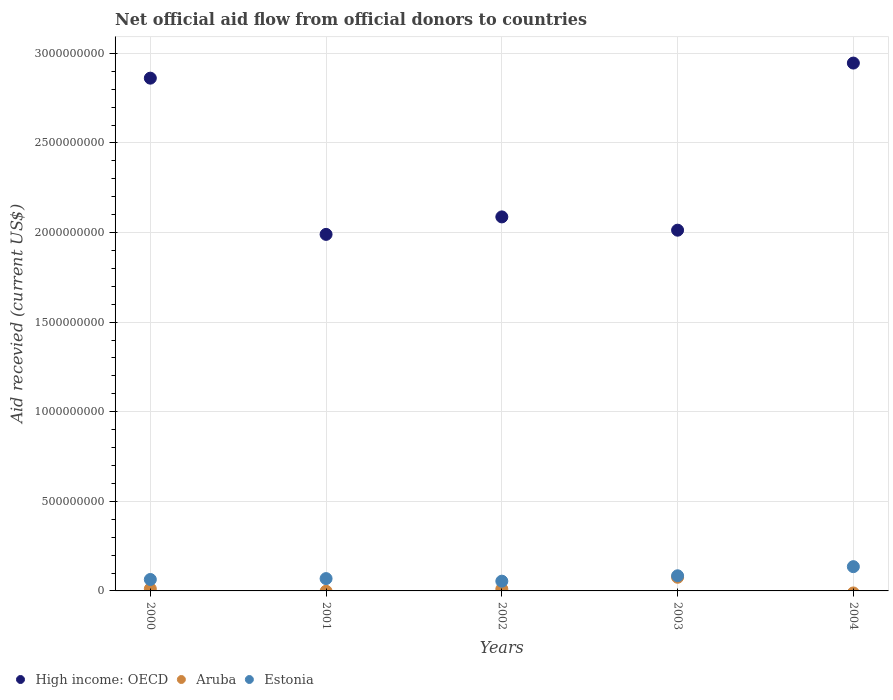What is the total aid received in High income: OECD in 2002?
Offer a very short reply. 2.09e+09. Across all years, what is the maximum total aid received in Estonia?
Offer a very short reply. 1.35e+08. Across all years, what is the minimum total aid received in Estonia?
Your response must be concise. 5.44e+07. In which year was the total aid received in Aruba maximum?
Offer a terse response. 2003. What is the total total aid received in Estonia in the graph?
Your response must be concise. 4.07e+08. What is the difference between the total aid received in Estonia in 2000 and that in 2002?
Your answer should be compact. 9.42e+06. What is the difference between the total aid received in Estonia in 2002 and the total aid received in Aruba in 2000?
Provide a succinct answer. 4.29e+07. What is the average total aid received in Estonia per year?
Ensure brevity in your answer.  8.14e+07. In the year 2002, what is the difference between the total aid received in Aruba and total aid received in Estonia?
Keep it short and to the point. -4.39e+07. What is the ratio of the total aid received in Estonia in 2001 to that in 2004?
Keep it short and to the point. 0.51. Is the difference between the total aid received in Aruba in 2000 and 2003 greater than the difference between the total aid received in Estonia in 2000 and 2003?
Give a very brief answer. No. What is the difference between the highest and the second highest total aid received in High income: OECD?
Give a very brief answer. 8.42e+07. What is the difference between the highest and the lowest total aid received in Aruba?
Offer a terse response. 7.62e+07. Is the sum of the total aid received in Estonia in 2001 and 2002 greater than the maximum total aid received in High income: OECD across all years?
Your response must be concise. No. Is it the case that in every year, the sum of the total aid received in Estonia and total aid received in Aruba  is greater than the total aid received in High income: OECD?
Your answer should be very brief. No. Does the total aid received in High income: OECD monotonically increase over the years?
Make the answer very short. No. Is the total aid received in Estonia strictly greater than the total aid received in Aruba over the years?
Give a very brief answer. Yes. Is the total aid received in High income: OECD strictly less than the total aid received in Estonia over the years?
Make the answer very short. No. How many dotlines are there?
Provide a succinct answer. 3. How many years are there in the graph?
Ensure brevity in your answer.  5. What is the difference between two consecutive major ticks on the Y-axis?
Provide a short and direct response. 5.00e+08. Does the graph contain any zero values?
Offer a terse response. Yes. Does the graph contain grids?
Offer a very short reply. Yes. How are the legend labels stacked?
Give a very brief answer. Horizontal. What is the title of the graph?
Give a very brief answer. Net official aid flow from official donors to countries. Does "North America" appear as one of the legend labels in the graph?
Your answer should be compact. No. What is the label or title of the Y-axis?
Offer a terse response. Aid recevied (current US$). What is the Aid recevied (current US$) in High income: OECD in 2000?
Offer a terse response. 2.86e+09. What is the Aid recevied (current US$) in Aruba in 2000?
Your answer should be compact. 1.15e+07. What is the Aid recevied (current US$) of Estonia in 2000?
Make the answer very short. 6.38e+07. What is the Aid recevied (current US$) in High income: OECD in 2001?
Offer a very short reply. 1.99e+09. What is the Aid recevied (current US$) of Estonia in 2001?
Ensure brevity in your answer.  6.88e+07. What is the Aid recevied (current US$) in High income: OECD in 2002?
Your answer should be compact. 2.09e+09. What is the Aid recevied (current US$) in Aruba in 2002?
Make the answer very short. 1.05e+07. What is the Aid recevied (current US$) of Estonia in 2002?
Ensure brevity in your answer.  5.44e+07. What is the Aid recevied (current US$) of High income: OECD in 2003?
Offer a very short reply. 2.01e+09. What is the Aid recevied (current US$) in Aruba in 2003?
Provide a short and direct response. 7.62e+07. What is the Aid recevied (current US$) of Estonia in 2003?
Keep it short and to the point. 8.45e+07. What is the Aid recevied (current US$) in High income: OECD in 2004?
Give a very brief answer. 2.95e+09. What is the Aid recevied (current US$) of Estonia in 2004?
Provide a short and direct response. 1.35e+08. Across all years, what is the maximum Aid recevied (current US$) of High income: OECD?
Make the answer very short. 2.95e+09. Across all years, what is the maximum Aid recevied (current US$) in Aruba?
Give a very brief answer. 7.62e+07. Across all years, what is the maximum Aid recevied (current US$) of Estonia?
Provide a succinct answer. 1.35e+08. Across all years, what is the minimum Aid recevied (current US$) in High income: OECD?
Your answer should be compact. 1.99e+09. Across all years, what is the minimum Aid recevied (current US$) of Estonia?
Your answer should be very brief. 5.44e+07. What is the total Aid recevied (current US$) of High income: OECD in the graph?
Offer a terse response. 1.19e+1. What is the total Aid recevied (current US$) in Aruba in the graph?
Your answer should be very brief. 9.82e+07. What is the total Aid recevied (current US$) in Estonia in the graph?
Provide a short and direct response. 4.07e+08. What is the difference between the Aid recevied (current US$) of High income: OECD in 2000 and that in 2001?
Your answer should be compact. 8.72e+08. What is the difference between the Aid recevied (current US$) of Estonia in 2000 and that in 2001?
Provide a short and direct response. -4.95e+06. What is the difference between the Aid recevied (current US$) in High income: OECD in 2000 and that in 2002?
Offer a very short reply. 7.74e+08. What is the difference between the Aid recevied (current US$) in Aruba in 2000 and that in 2002?
Provide a short and direct response. 1.01e+06. What is the difference between the Aid recevied (current US$) of Estonia in 2000 and that in 2002?
Your answer should be compact. 9.42e+06. What is the difference between the Aid recevied (current US$) in High income: OECD in 2000 and that in 2003?
Provide a succinct answer. 8.48e+08. What is the difference between the Aid recevied (current US$) of Aruba in 2000 and that in 2003?
Offer a terse response. -6.47e+07. What is the difference between the Aid recevied (current US$) in Estonia in 2000 and that in 2003?
Your answer should be very brief. -2.07e+07. What is the difference between the Aid recevied (current US$) of High income: OECD in 2000 and that in 2004?
Give a very brief answer. -8.42e+07. What is the difference between the Aid recevied (current US$) in Estonia in 2000 and that in 2004?
Your answer should be very brief. -7.16e+07. What is the difference between the Aid recevied (current US$) in High income: OECD in 2001 and that in 2002?
Your answer should be very brief. -9.76e+07. What is the difference between the Aid recevied (current US$) of Estonia in 2001 and that in 2002?
Your answer should be very brief. 1.44e+07. What is the difference between the Aid recevied (current US$) of High income: OECD in 2001 and that in 2003?
Ensure brevity in your answer.  -2.34e+07. What is the difference between the Aid recevied (current US$) of Estonia in 2001 and that in 2003?
Keep it short and to the point. -1.57e+07. What is the difference between the Aid recevied (current US$) in High income: OECD in 2001 and that in 2004?
Offer a terse response. -9.56e+08. What is the difference between the Aid recevied (current US$) in Estonia in 2001 and that in 2004?
Provide a succinct answer. -6.66e+07. What is the difference between the Aid recevied (current US$) in High income: OECD in 2002 and that in 2003?
Provide a succinct answer. 7.41e+07. What is the difference between the Aid recevied (current US$) in Aruba in 2002 and that in 2003?
Give a very brief answer. -6.57e+07. What is the difference between the Aid recevied (current US$) in Estonia in 2002 and that in 2003?
Provide a succinct answer. -3.01e+07. What is the difference between the Aid recevied (current US$) of High income: OECD in 2002 and that in 2004?
Your answer should be very brief. -8.58e+08. What is the difference between the Aid recevied (current US$) in Estonia in 2002 and that in 2004?
Your answer should be very brief. -8.10e+07. What is the difference between the Aid recevied (current US$) in High income: OECD in 2003 and that in 2004?
Your response must be concise. -9.33e+08. What is the difference between the Aid recevied (current US$) of Estonia in 2003 and that in 2004?
Make the answer very short. -5.09e+07. What is the difference between the Aid recevied (current US$) in High income: OECD in 2000 and the Aid recevied (current US$) in Estonia in 2001?
Ensure brevity in your answer.  2.79e+09. What is the difference between the Aid recevied (current US$) of Aruba in 2000 and the Aid recevied (current US$) of Estonia in 2001?
Your response must be concise. -5.73e+07. What is the difference between the Aid recevied (current US$) of High income: OECD in 2000 and the Aid recevied (current US$) of Aruba in 2002?
Your answer should be compact. 2.85e+09. What is the difference between the Aid recevied (current US$) of High income: OECD in 2000 and the Aid recevied (current US$) of Estonia in 2002?
Your answer should be very brief. 2.81e+09. What is the difference between the Aid recevied (current US$) in Aruba in 2000 and the Aid recevied (current US$) in Estonia in 2002?
Provide a short and direct response. -4.29e+07. What is the difference between the Aid recevied (current US$) of High income: OECD in 2000 and the Aid recevied (current US$) of Aruba in 2003?
Your answer should be very brief. 2.79e+09. What is the difference between the Aid recevied (current US$) in High income: OECD in 2000 and the Aid recevied (current US$) in Estonia in 2003?
Give a very brief answer. 2.78e+09. What is the difference between the Aid recevied (current US$) of Aruba in 2000 and the Aid recevied (current US$) of Estonia in 2003?
Make the answer very short. -7.30e+07. What is the difference between the Aid recevied (current US$) in High income: OECD in 2000 and the Aid recevied (current US$) in Estonia in 2004?
Ensure brevity in your answer.  2.73e+09. What is the difference between the Aid recevied (current US$) in Aruba in 2000 and the Aid recevied (current US$) in Estonia in 2004?
Make the answer very short. -1.24e+08. What is the difference between the Aid recevied (current US$) of High income: OECD in 2001 and the Aid recevied (current US$) of Aruba in 2002?
Provide a succinct answer. 1.98e+09. What is the difference between the Aid recevied (current US$) of High income: OECD in 2001 and the Aid recevied (current US$) of Estonia in 2002?
Your answer should be compact. 1.94e+09. What is the difference between the Aid recevied (current US$) of High income: OECD in 2001 and the Aid recevied (current US$) of Aruba in 2003?
Offer a very short reply. 1.91e+09. What is the difference between the Aid recevied (current US$) of High income: OECD in 2001 and the Aid recevied (current US$) of Estonia in 2003?
Provide a short and direct response. 1.91e+09. What is the difference between the Aid recevied (current US$) in High income: OECD in 2001 and the Aid recevied (current US$) in Estonia in 2004?
Give a very brief answer. 1.85e+09. What is the difference between the Aid recevied (current US$) in High income: OECD in 2002 and the Aid recevied (current US$) in Aruba in 2003?
Ensure brevity in your answer.  2.01e+09. What is the difference between the Aid recevied (current US$) in High income: OECD in 2002 and the Aid recevied (current US$) in Estonia in 2003?
Your answer should be very brief. 2.00e+09. What is the difference between the Aid recevied (current US$) of Aruba in 2002 and the Aid recevied (current US$) of Estonia in 2003?
Make the answer very short. -7.40e+07. What is the difference between the Aid recevied (current US$) in High income: OECD in 2002 and the Aid recevied (current US$) in Estonia in 2004?
Provide a short and direct response. 1.95e+09. What is the difference between the Aid recevied (current US$) of Aruba in 2002 and the Aid recevied (current US$) of Estonia in 2004?
Make the answer very short. -1.25e+08. What is the difference between the Aid recevied (current US$) of High income: OECD in 2003 and the Aid recevied (current US$) of Estonia in 2004?
Offer a very short reply. 1.88e+09. What is the difference between the Aid recevied (current US$) in Aruba in 2003 and the Aid recevied (current US$) in Estonia in 2004?
Offer a terse response. -5.92e+07. What is the average Aid recevied (current US$) of High income: OECD per year?
Provide a succinct answer. 2.38e+09. What is the average Aid recevied (current US$) in Aruba per year?
Offer a very short reply. 1.96e+07. What is the average Aid recevied (current US$) in Estonia per year?
Your answer should be compact. 8.14e+07. In the year 2000, what is the difference between the Aid recevied (current US$) in High income: OECD and Aid recevied (current US$) in Aruba?
Provide a short and direct response. 2.85e+09. In the year 2000, what is the difference between the Aid recevied (current US$) in High income: OECD and Aid recevied (current US$) in Estonia?
Provide a succinct answer. 2.80e+09. In the year 2000, what is the difference between the Aid recevied (current US$) of Aruba and Aid recevied (current US$) of Estonia?
Give a very brief answer. -5.23e+07. In the year 2001, what is the difference between the Aid recevied (current US$) of High income: OECD and Aid recevied (current US$) of Estonia?
Your answer should be very brief. 1.92e+09. In the year 2002, what is the difference between the Aid recevied (current US$) of High income: OECD and Aid recevied (current US$) of Aruba?
Provide a short and direct response. 2.08e+09. In the year 2002, what is the difference between the Aid recevied (current US$) of High income: OECD and Aid recevied (current US$) of Estonia?
Your response must be concise. 2.03e+09. In the year 2002, what is the difference between the Aid recevied (current US$) in Aruba and Aid recevied (current US$) in Estonia?
Ensure brevity in your answer.  -4.39e+07. In the year 2003, what is the difference between the Aid recevied (current US$) in High income: OECD and Aid recevied (current US$) in Aruba?
Give a very brief answer. 1.94e+09. In the year 2003, what is the difference between the Aid recevied (current US$) in High income: OECD and Aid recevied (current US$) in Estonia?
Your response must be concise. 1.93e+09. In the year 2003, what is the difference between the Aid recevied (current US$) of Aruba and Aid recevied (current US$) of Estonia?
Offer a terse response. -8.28e+06. In the year 2004, what is the difference between the Aid recevied (current US$) in High income: OECD and Aid recevied (current US$) in Estonia?
Make the answer very short. 2.81e+09. What is the ratio of the Aid recevied (current US$) in High income: OECD in 2000 to that in 2001?
Offer a very short reply. 1.44. What is the ratio of the Aid recevied (current US$) of Estonia in 2000 to that in 2001?
Make the answer very short. 0.93. What is the ratio of the Aid recevied (current US$) of High income: OECD in 2000 to that in 2002?
Your answer should be very brief. 1.37. What is the ratio of the Aid recevied (current US$) of Aruba in 2000 to that in 2002?
Give a very brief answer. 1.1. What is the ratio of the Aid recevied (current US$) of Estonia in 2000 to that in 2002?
Offer a very short reply. 1.17. What is the ratio of the Aid recevied (current US$) of High income: OECD in 2000 to that in 2003?
Offer a very short reply. 1.42. What is the ratio of the Aid recevied (current US$) in Aruba in 2000 to that in 2003?
Your answer should be compact. 0.15. What is the ratio of the Aid recevied (current US$) of Estonia in 2000 to that in 2003?
Offer a terse response. 0.76. What is the ratio of the Aid recevied (current US$) in High income: OECD in 2000 to that in 2004?
Make the answer very short. 0.97. What is the ratio of the Aid recevied (current US$) of Estonia in 2000 to that in 2004?
Make the answer very short. 0.47. What is the ratio of the Aid recevied (current US$) in High income: OECD in 2001 to that in 2002?
Keep it short and to the point. 0.95. What is the ratio of the Aid recevied (current US$) of Estonia in 2001 to that in 2002?
Provide a short and direct response. 1.26. What is the ratio of the Aid recevied (current US$) in High income: OECD in 2001 to that in 2003?
Keep it short and to the point. 0.99. What is the ratio of the Aid recevied (current US$) of Estonia in 2001 to that in 2003?
Offer a very short reply. 0.81. What is the ratio of the Aid recevied (current US$) of High income: OECD in 2001 to that in 2004?
Give a very brief answer. 0.68. What is the ratio of the Aid recevied (current US$) in Estonia in 2001 to that in 2004?
Your answer should be very brief. 0.51. What is the ratio of the Aid recevied (current US$) in High income: OECD in 2002 to that in 2003?
Offer a terse response. 1.04. What is the ratio of the Aid recevied (current US$) of Aruba in 2002 to that in 2003?
Provide a short and direct response. 0.14. What is the ratio of the Aid recevied (current US$) of Estonia in 2002 to that in 2003?
Ensure brevity in your answer.  0.64. What is the ratio of the Aid recevied (current US$) in High income: OECD in 2002 to that in 2004?
Offer a terse response. 0.71. What is the ratio of the Aid recevied (current US$) of Estonia in 2002 to that in 2004?
Your response must be concise. 0.4. What is the ratio of the Aid recevied (current US$) in High income: OECD in 2003 to that in 2004?
Your answer should be very brief. 0.68. What is the ratio of the Aid recevied (current US$) in Estonia in 2003 to that in 2004?
Give a very brief answer. 0.62. What is the difference between the highest and the second highest Aid recevied (current US$) in High income: OECD?
Provide a short and direct response. 8.42e+07. What is the difference between the highest and the second highest Aid recevied (current US$) in Aruba?
Your answer should be compact. 6.47e+07. What is the difference between the highest and the second highest Aid recevied (current US$) in Estonia?
Provide a succinct answer. 5.09e+07. What is the difference between the highest and the lowest Aid recevied (current US$) in High income: OECD?
Offer a very short reply. 9.56e+08. What is the difference between the highest and the lowest Aid recevied (current US$) of Aruba?
Keep it short and to the point. 7.62e+07. What is the difference between the highest and the lowest Aid recevied (current US$) in Estonia?
Make the answer very short. 8.10e+07. 